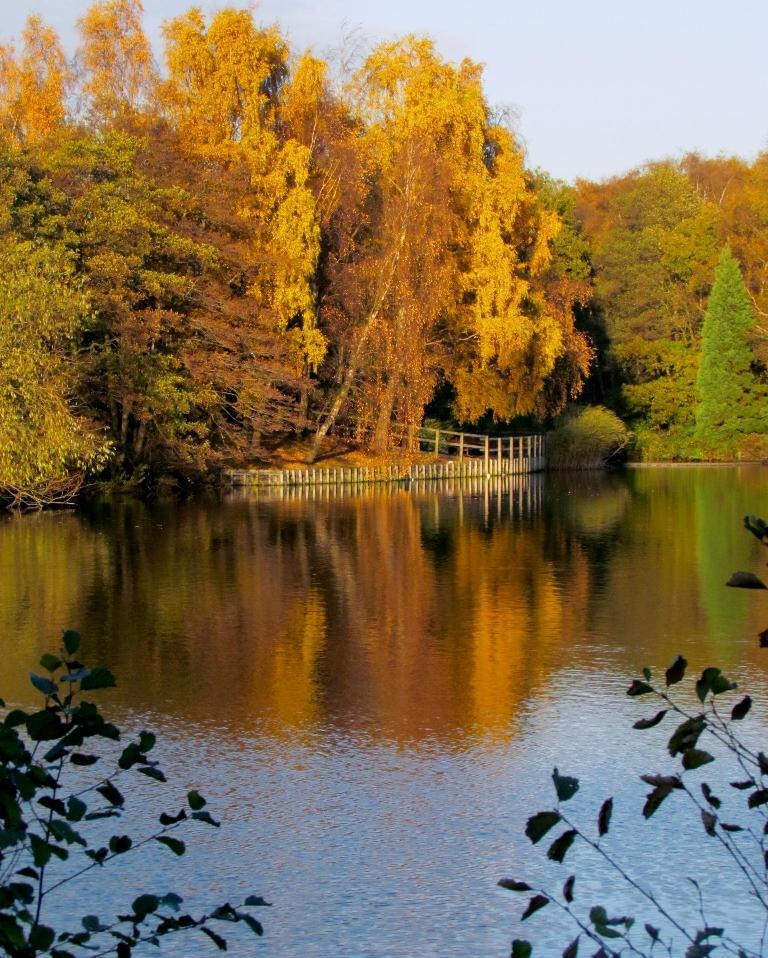Can you describe this image briefly? In this image, there is a river and there is water, there are some plants and trees, at the top there is a sky which is cloudy and in white color. 